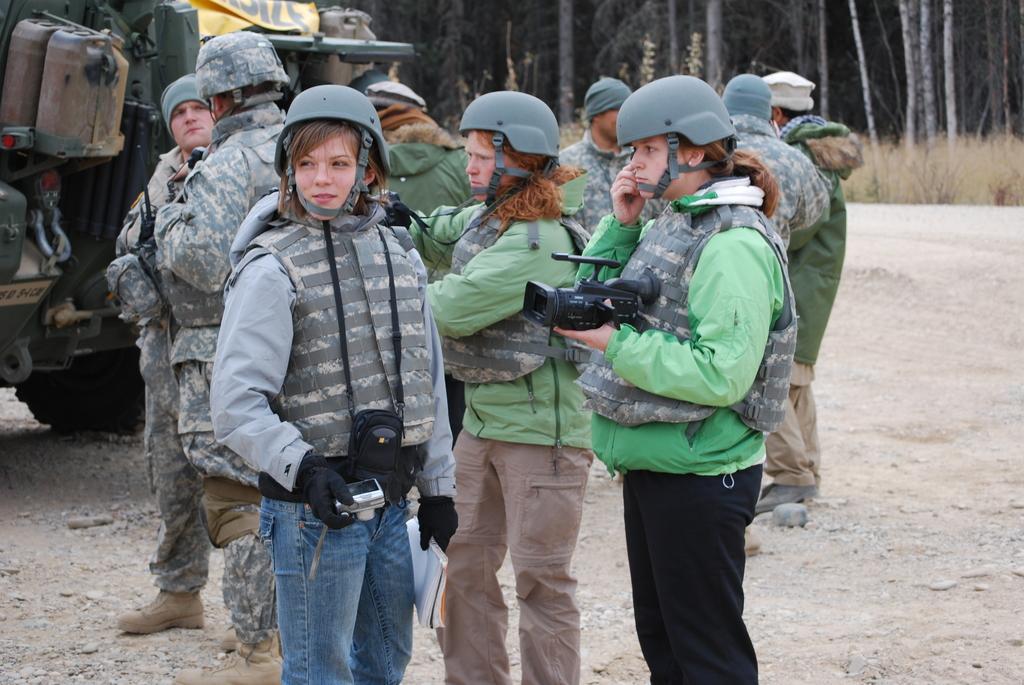Can you describe this image briefly? In this picture we can observe some people standing on the land. All of them are wearing helmets on their heads. Some of them or holding cameras in their hands. We can observe men and women in this picture. On the left right there is a vehicle. In the background there are trees and grass on the ground. 